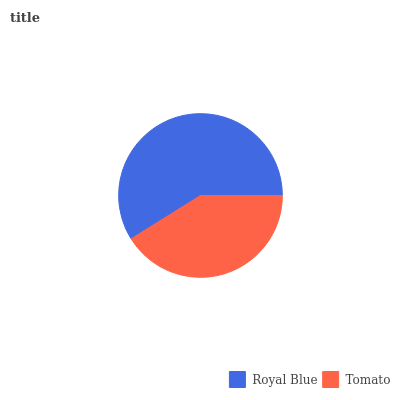Is Tomato the minimum?
Answer yes or no. Yes. Is Royal Blue the maximum?
Answer yes or no. Yes. Is Tomato the maximum?
Answer yes or no. No. Is Royal Blue greater than Tomato?
Answer yes or no. Yes. Is Tomato less than Royal Blue?
Answer yes or no. Yes. Is Tomato greater than Royal Blue?
Answer yes or no. No. Is Royal Blue less than Tomato?
Answer yes or no. No. Is Royal Blue the high median?
Answer yes or no. Yes. Is Tomato the low median?
Answer yes or no. Yes. Is Tomato the high median?
Answer yes or no. No. Is Royal Blue the low median?
Answer yes or no. No. 